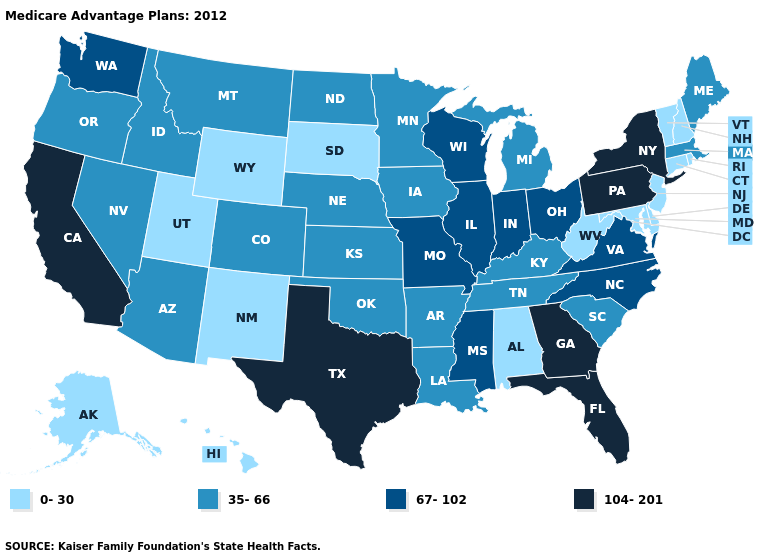Does Delaware have the highest value in the South?
Answer briefly. No. How many symbols are there in the legend?
Write a very short answer. 4. Does Georgia have the highest value in the USA?
Write a very short answer. Yes. What is the value of Minnesota?
Give a very brief answer. 35-66. Does the first symbol in the legend represent the smallest category?
Give a very brief answer. Yes. What is the lowest value in states that border Nevada?
Be succinct. 0-30. Does California have the highest value in the USA?
Write a very short answer. Yes. What is the value of Montana?
Short answer required. 35-66. What is the value of Maryland?
Concise answer only. 0-30. What is the highest value in the USA?
Answer briefly. 104-201. Among the states that border Missouri , does Oklahoma have the highest value?
Give a very brief answer. No. Does Tennessee have a lower value than Delaware?
Write a very short answer. No. Does Utah have the highest value in the West?
Be succinct. No. Name the states that have a value in the range 104-201?
Be succinct. California, Florida, Georgia, New York, Pennsylvania, Texas. Does the map have missing data?
Quick response, please. No. 